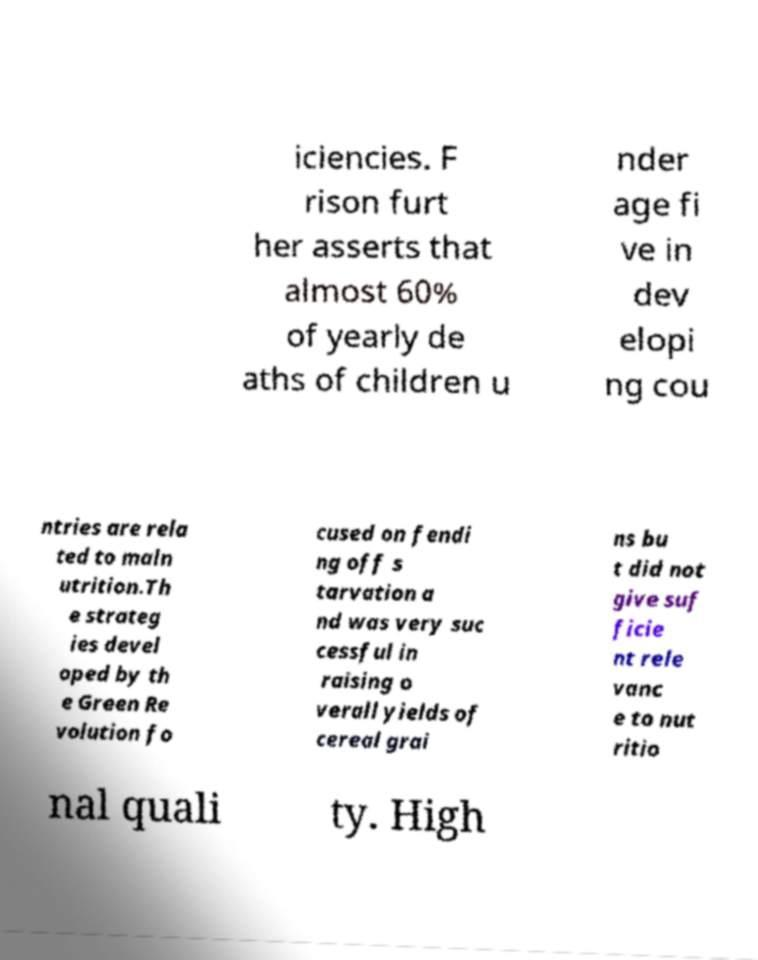Can you accurately transcribe the text from the provided image for me? iciencies. F rison furt her asserts that almost 60% of yearly de aths of children u nder age fi ve in dev elopi ng cou ntries are rela ted to maln utrition.Th e strateg ies devel oped by th e Green Re volution fo cused on fendi ng off s tarvation a nd was very suc cessful in raising o verall yields of cereal grai ns bu t did not give suf ficie nt rele vanc e to nut ritio nal quali ty. High 